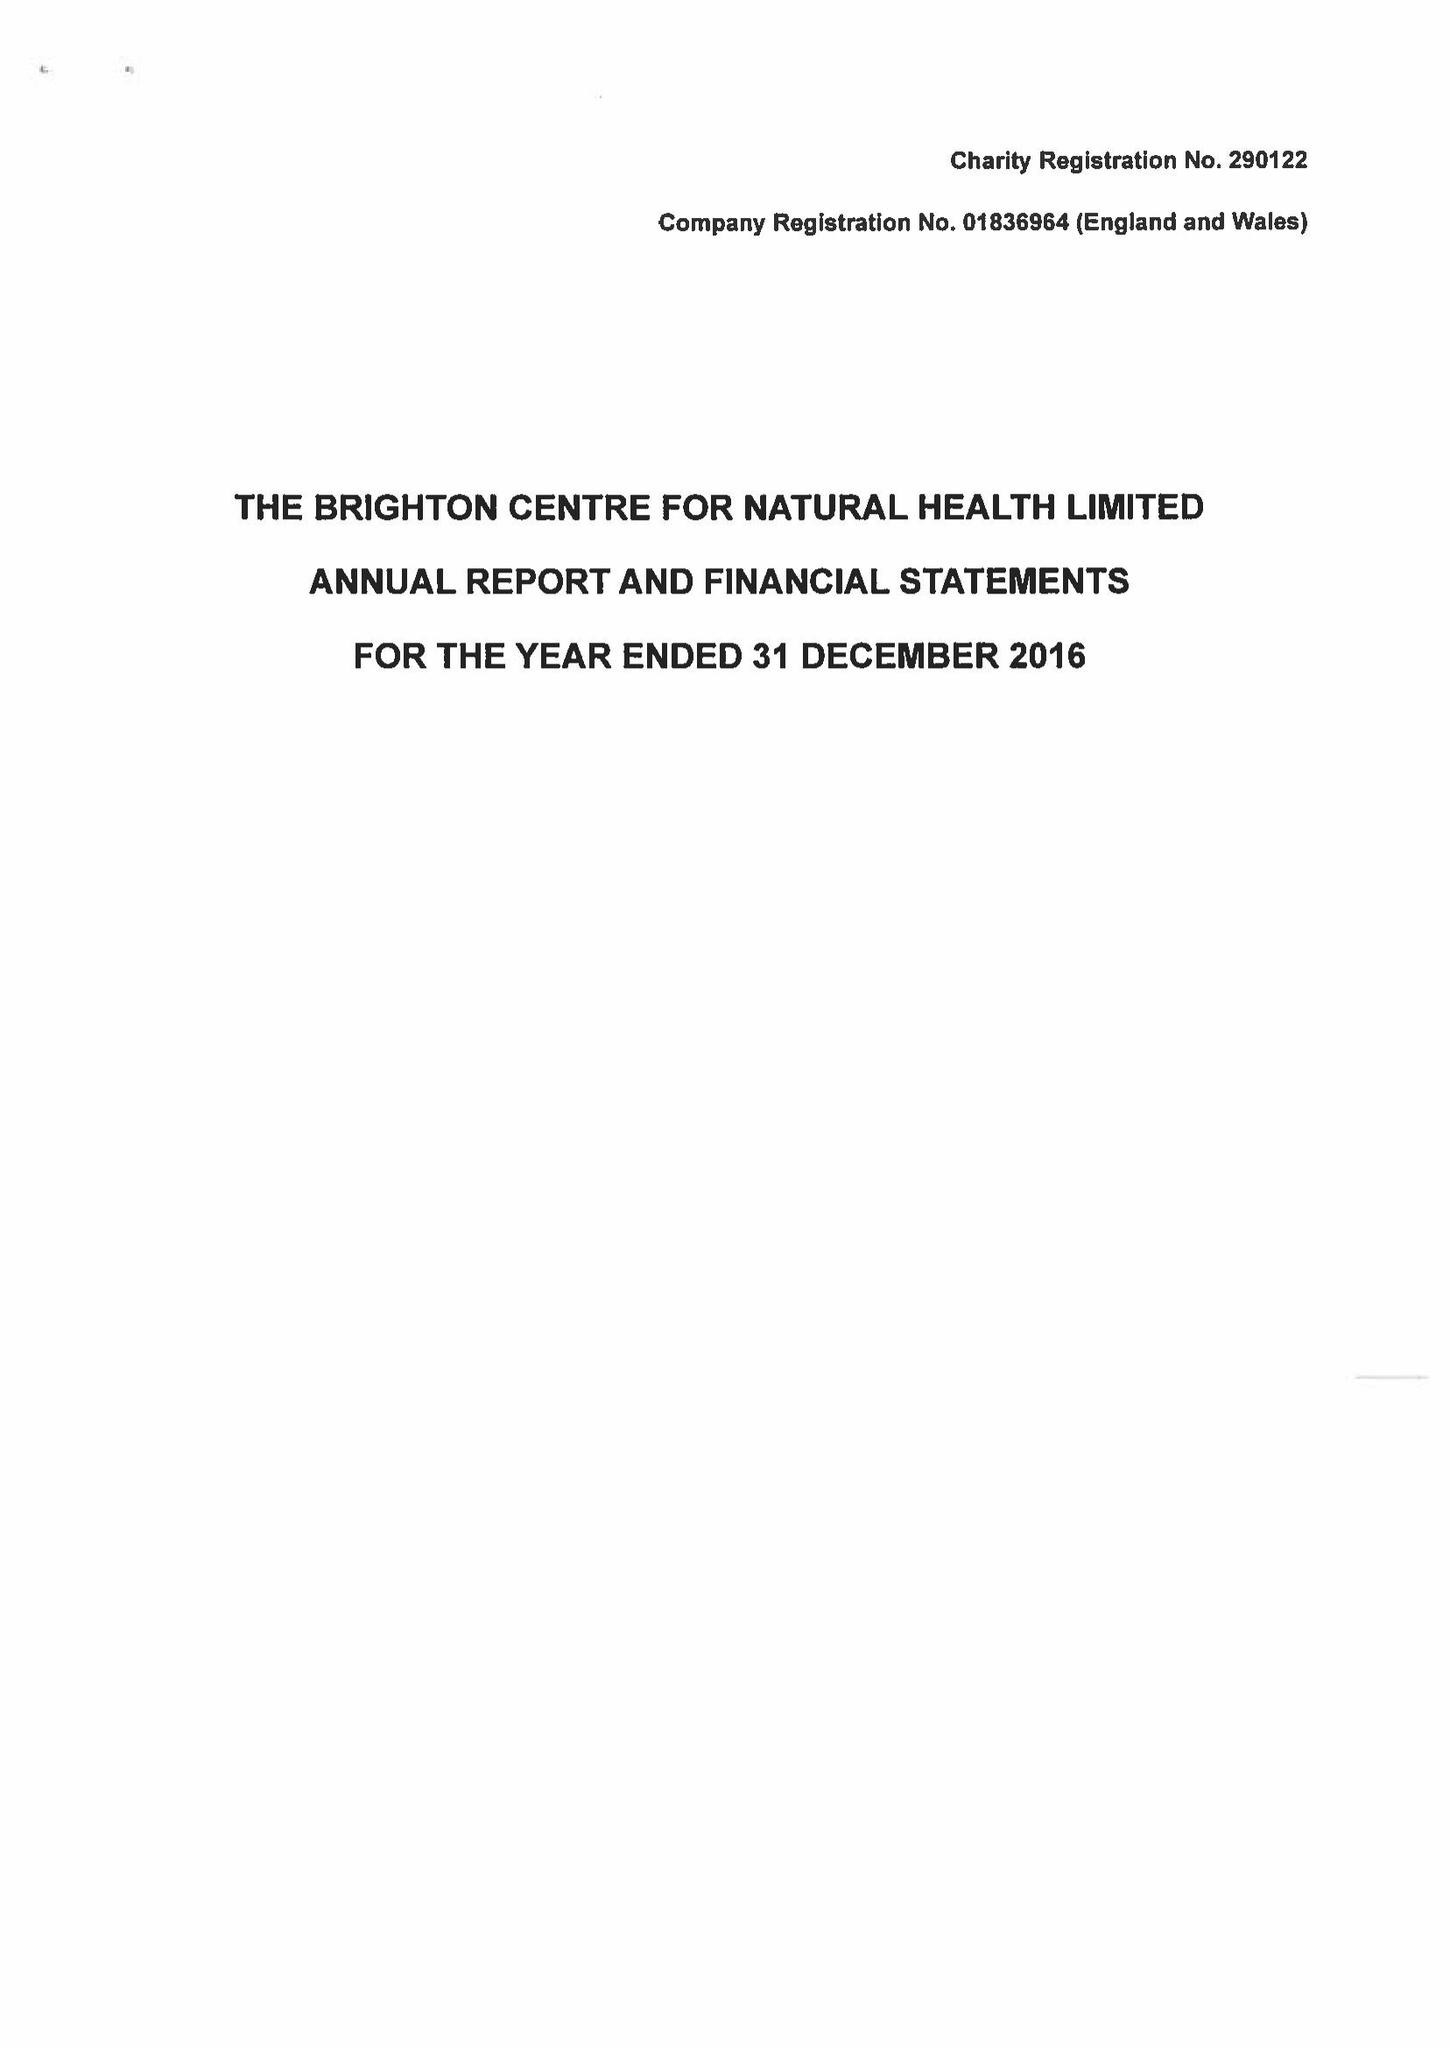What is the value for the address__postcode?
Answer the question using a single word or phrase. BN1 1UL 